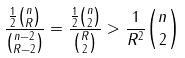Convert formula to latex. <formula><loc_0><loc_0><loc_500><loc_500>\frac { \frac { 1 } { 2 } \binom { n } { R } } { \binom { n - 2 } { R - 2 } } = \frac { \frac { 1 } { 2 } \binom { n } { 2 } } { \binom { R } { 2 } } > \frac { 1 } { R ^ { 2 } } \binom { n } { 2 }</formula> 